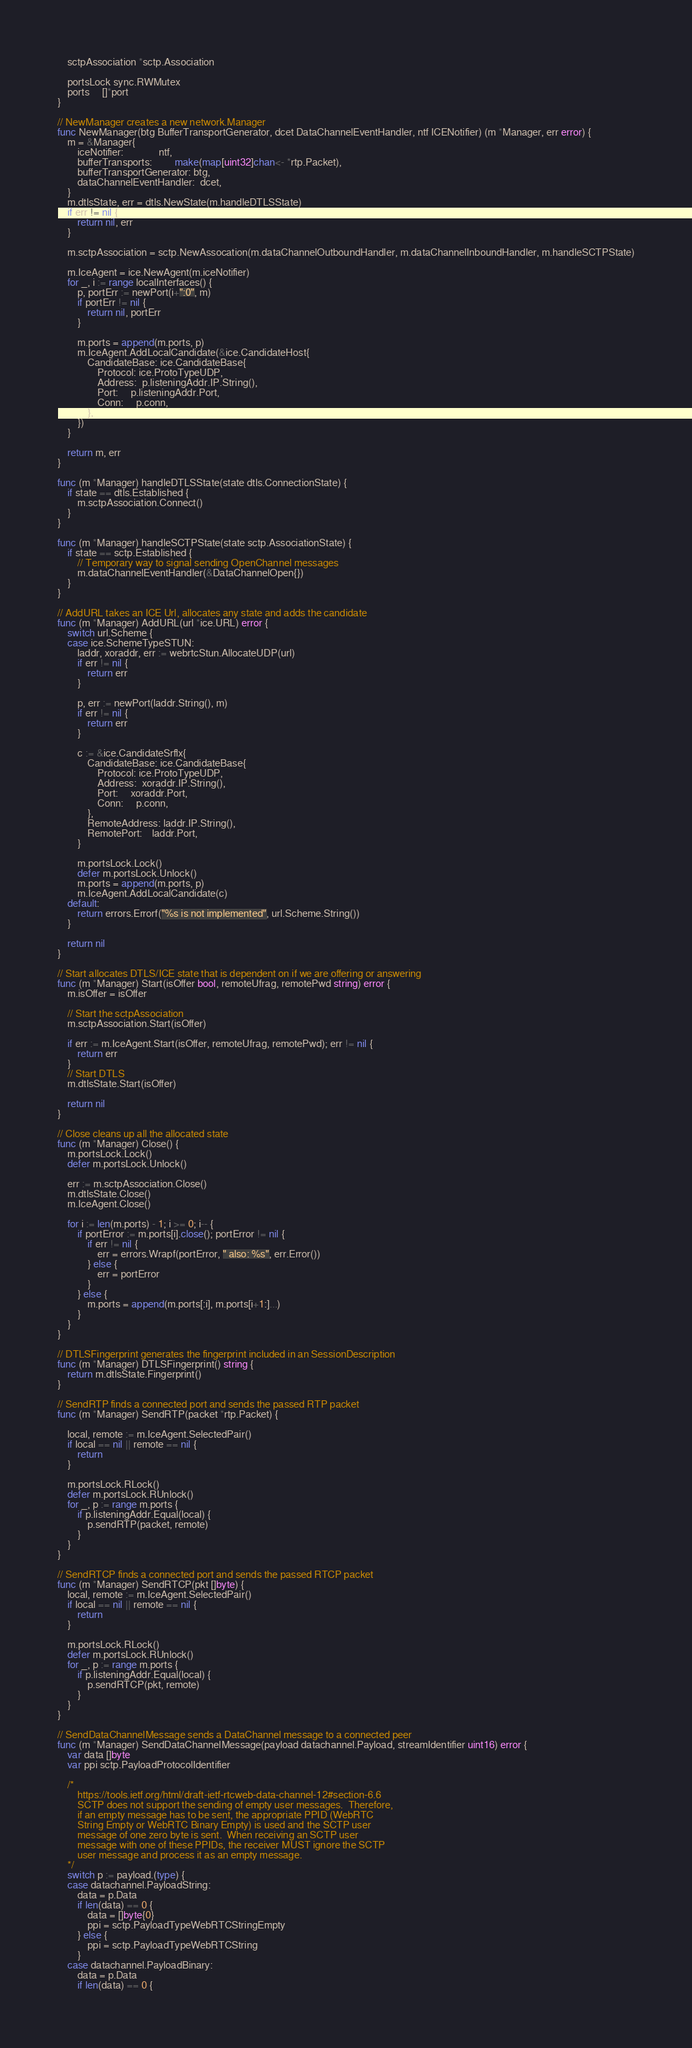Convert code to text. <code><loc_0><loc_0><loc_500><loc_500><_Go_>
	sctpAssociation *sctp.Association

	portsLock sync.RWMutex
	ports     []*port
}

// NewManager creates a new network.Manager
func NewManager(btg BufferTransportGenerator, dcet DataChannelEventHandler, ntf ICENotifier) (m *Manager, err error) {
	m = &Manager{
		iceNotifier:              ntf,
		bufferTransports:         make(map[uint32]chan<- *rtp.Packet),
		bufferTransportGenerator: btg,
		dataChannelEventHandler:  dcet,
	}
	m.dtlsState, err = dtls.NewState(m.handleDTLSState)
	if err != nil {
		return nil, err
	}

	m.sctpAssociation = sctp.NewAssocation(m.dataChannelOutboundHandler, m.dataChannelInboundHandler, m.handleSCTPState)

	m.IceAgent = ice.NewAgent(m.iceNotifier)
	for _, i := range localInterfaces() {
		p, portErr := newPort(i+":0", m)
		if portErr != nil {
			return nil, portErr
		}

		m.ports = append(m.ports, p)
		m.IceAgent.AddLocalCandidate(&ice.CandidateHost{
			CandidateBase: ice.CandidateBase{
				Protocol: ice.ProtoTypeUDP,
				Address:  p.listeningAddr.IP.String(),
				Port:     p.listeningAddr.Port,
				Conn:     p.conn,
			},
		})
	}

	return m, err
}

func (m *Manager) handleDTLSState(state dtls.ConnectionState) {
	if state == dtls.Established {
		m.sctpAssociation.Connect()
	}
}

func (m *Manager) handleSCTPState(state sctp.AssociationState) {
	if state == sctp.Established {
		// Temporary way to signal sending OpenChannel messages
		m.dataChannelEventHandler(&DataChannelOpen{})
	}
}

// AddURL takes an ICE Url, allocates any state and adds the candidate
func (m *Manager) AddURL(url *ice.URL) error {
	switch url.Scheme {
	case ice.SchemeTypeSTUN:
		laddr, xoraddr, err := webrtcStun.AllocateUDP(url)
		if err != nil {
			return err
		}

		p, err := newPort(laddr.String(), m)
		if err != nil {
			return err
		}

		c := &ice.CandidateSrflx{
			CandidateBase: ice.CandidateBase{
				Protocol: ice.ProtoTypeUDP,
				Address:  xoraddr.IP.String(),
				Port:     xoraddr.Port,
				Conn:     p.conn,
			},
			RemoteAddress: laddr.IP.String(),
			RemotePort:    laddr.Port,
		}

		m.portsLock.Lock()
		defer m.portsLock.Unlock()
		m.ports = append(m.ports, p)
		m.IceAgent.AddLocalCandidate(c)
	default:
		return errors.Errorf("%s is not implemented", url.Scheme.String())
	}

	return nil
}

// Start allocates DTLS/ICE state that is dependent on if we are offering or answering
func (m *Manager) Start(isOffer bool, remoteUfrag, remotePwd string) error {
	m.isOffer = isOffer

	// Start the sctpAssociation
	m.sctpAssociation.Start(isOffer)

	if err := m.IceAgent.Start(isOffer, remoteUfrag, remotePwd); err != nil {
		return err
	}
	// Start DTLS
	m.dtlsState.Start(isOffer)

	return nil
}

// Close cleans up all the allocated state
func (m *Manager) Close() {
	m.portsLock.Lock()
	defer m.portsLock.Unlock()

	err := m.sctpAssociation.Close()
	m.dtlsState.Close()
	m.IceAgent.Close()

	for i := len(m.ports) - 1; i >= 0; i-- {
		if portError := m.ports[i].close(); portError != nil {
			if err != nil {
				err = errors.Wrapf(portError, " also: %s", err.Error())
			} else {
				err = portError
			}
		} else {
			m.ports = append(m.ports[:i], m.ports[i+1:]...)
		}
	}
}

// DTLSFingerprint generates the fingerprint included in an SessionDescription
func (m *Manager) DTLSFingerprint() string {
	return m.dtlsState.Fingerprint()
}

// SendRTP finds a connected port and sends the passed RTP packet
func (m *Manager) SendRTP(packet *rtp.Packet) {

	local, remote := m.IceAgent.SelectedPair()
	if local == nil || remote == nil {
		return
	}

	m.portsLock.RLock()
	defer m.portsLock.RUnlock()
	for _, p := range m.ports {
		if p.listeningAddr.Equal(local) {
			p.sendRTP(packet, remote)
		}
	}
}

// SendRTCP finds a connected port and sends the passed RTCP packet
func (m *Manager) SendRTCP(pkt []byte) {
	local, remote := m.IceAgent.SelectedPair()
	if local == nil || remote == nil {
		return
	}

	m.portsLock.RLock()
	defer m.portsLock.RUnlock()
	for _, p := range m.ports {
		if p.listeningAddr.Equal(local) {
			p.sendRTCP(pkt, remote)
		}
	}
}

// SendDataChannelMessage sends a DataChannel message to a connected peer
func (m *Manager) SendDataChannelMessage(payload datachannel.Payload, streamIdentifier uint16) error {
	var data []byte
	var ppi sctp.PayloadProtocolIdentifier

	/*
		https://tools.ietf.org/html/draft-ietf-rtcweb-data-channel-12#section-6.6
		SCTP does not support the sending of empty user messages.  Therefore,
		if an empty message has to be sent, the appropriate PPID (WebRTC
		String Empty or WebRTC Binary Empty) is used and the SCTP user
		message of one zero byte is sent.  When receiving an SCTP user
		message with one of these PPIDs, the receiver MUST ignore the SCTP
		user message and process it as an empty message.
	*/
	switch p := payload.(type) {
	case datachannel.PayloadString:
		data = p.Data
		if len(data) == 0 {
			data = []byte{0}
			ppi = sctp.PayloadTypeWebRTCStringEmpty
		} else {
			ppi = sctp.PayloadTypeWebRTCString
		}
	case datachannel.PayloadBinary:
		data = p.Data
		if len(data) == 0 {</code> 